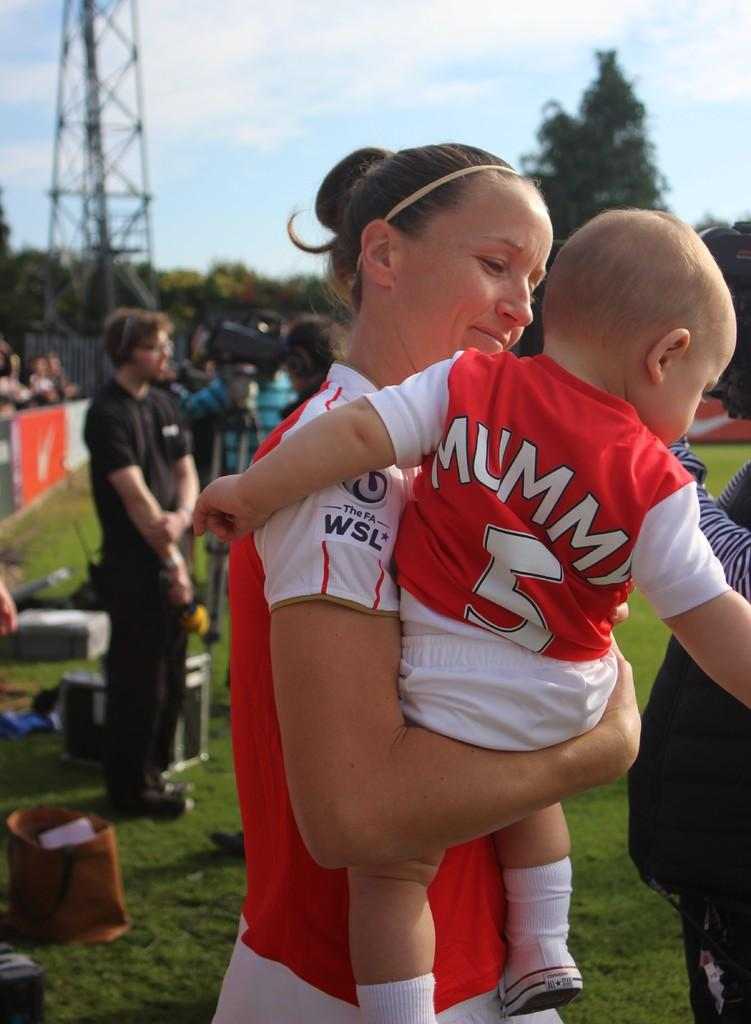<image>
Write a terse but informative summary of the picture. a lady holding a baby with mummy on his shirt 